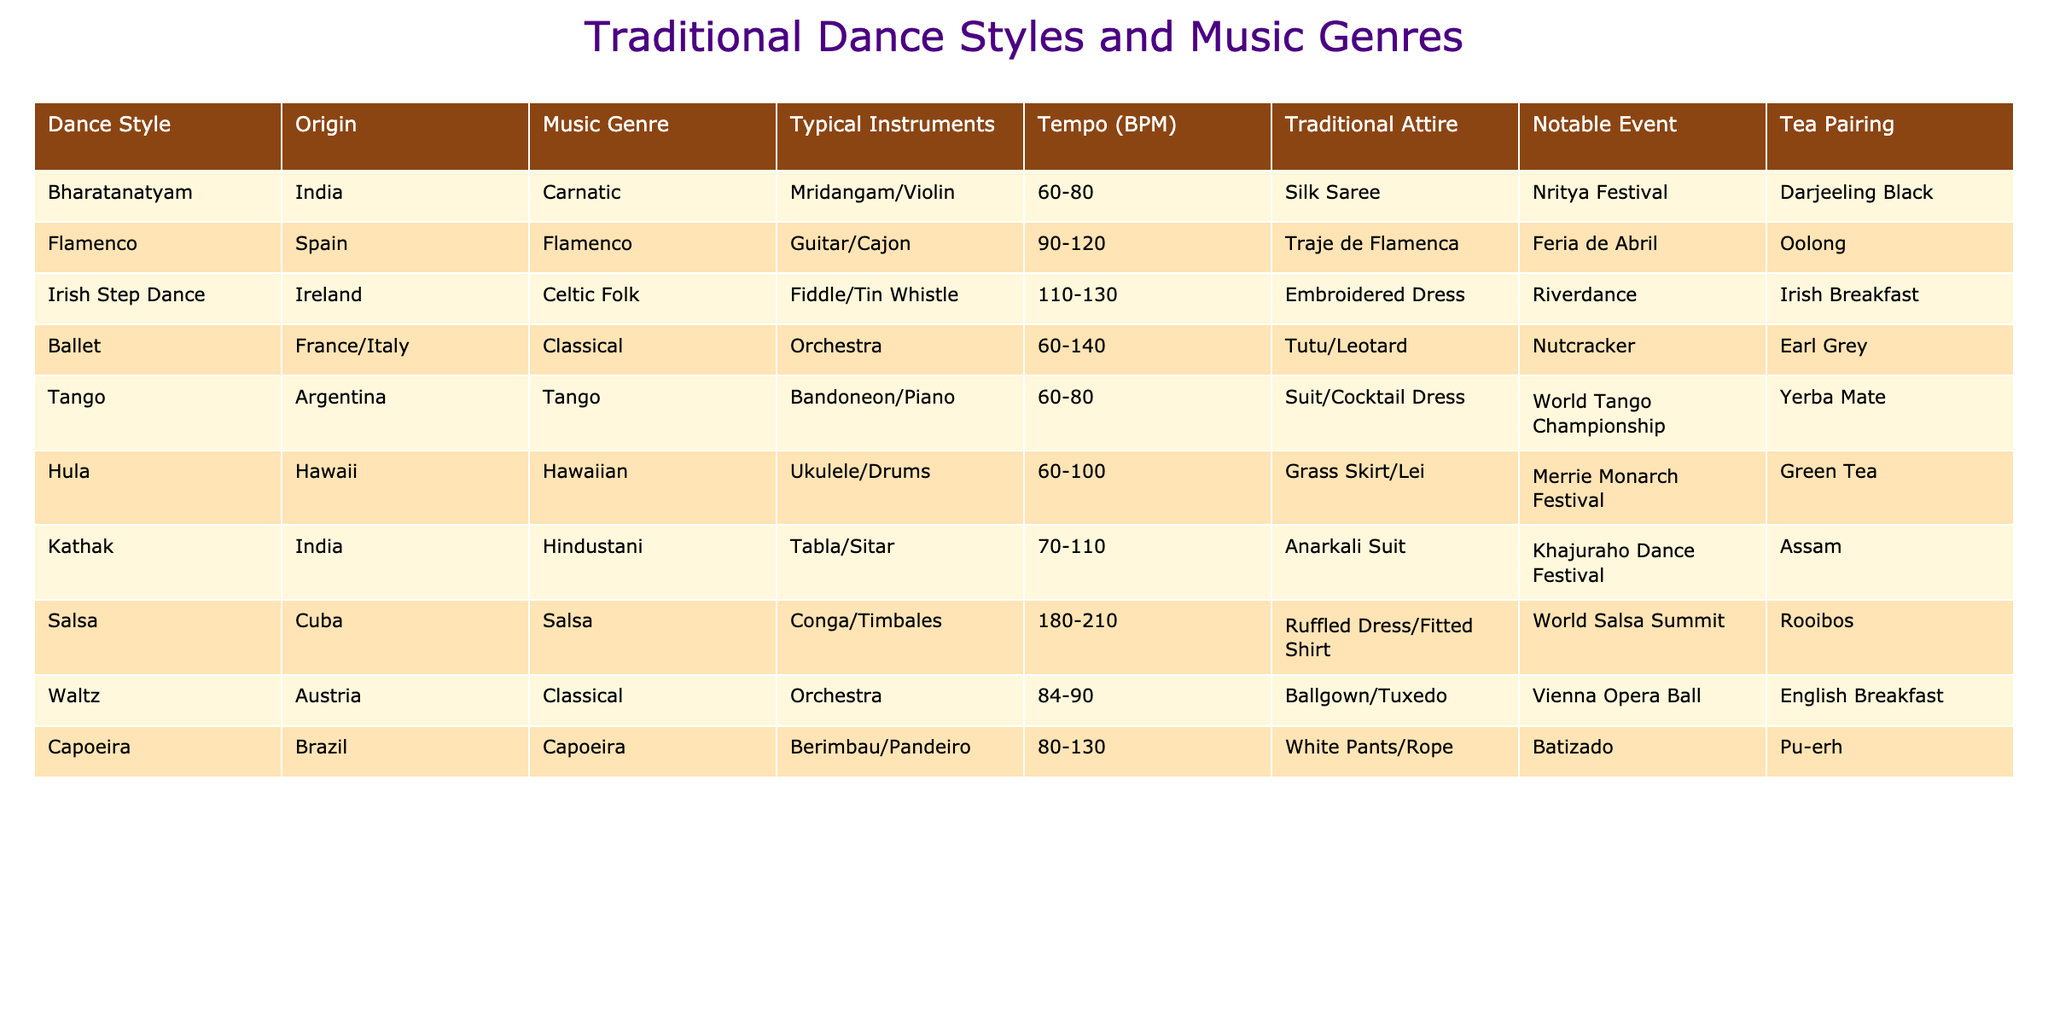What is the typical attire for Irish Step Dance? The table shows that the traditional attire for Irish Step Dance is an embroidered dress.
Answer: Embroidered dress Which dance style has a slower tempo, Bharatanatyam or Hula? Bharatanatyam has a tempo of 60-80 BPM, while Hula has a tempo of 60-100 BPM. Since 60-80 BPM is lower than 60-100 BPM, Bharatanatyam is the slower dance style.
Answer: Bharatanatyam What instrument is commonly associated with Tango? The table lists the Bandoneon and Piano as the typical instruments for Tango.
Answer: Bandoneon and Piano Is Salsa typically performed faster than Flamenco? The tempo for Salsa is 180-210 BPM, and for Flamenco it is 90-120 BPM. Since 180-210 BPM is higher than 90-120 BPM, Salsa is faster than Flamenco.
Answer: Yes Which dance style's typical music genre is Hindustani? The table indicates that Kathak corresponds with the Hindustani music genre.
Answer: Kathak What is the average tempo of Capoeira and Hula? Capoeira's tempo is 80-130 BPM, and Hula's is 60-100 BPM. To find the average, we consider the range of both: for Capoeira, the average is (80 + 130) / 2 = 105 BPM, and for Hula, it is (60 + 100) / 2 = 80 BPM. Then we average those two averages: (105 + 80) / 2 = 92.5 BPM.
Answer: 92.5 BPM Which traditional event is associated with Ballet? According to the table, Ballet is associated with the Nutcracker event.
Answer: Nutcracker Does the table show any dance styles that originate from India? Yes, both Bharatanatyam and Kathak are listed as dance styles originating from India.
Answer: Yes What is the tea pairing for Flamenco? The table indicates that the tea pairing for Flamenco is Oolong.
Answer: Oolong Among the listed dance styles, which one has the highest BPM range? Salsa has a tempo range of 180-210 BPM, which is higher than any other dance style listed in the table.
Answer: Salsa What traditional attire is worn for the World Salsa Summit? The table states that the attire for the World Salsa Summit is a ruffled dress or fitted shirt.
Answer: Ruffled dress/Fitted shirt 